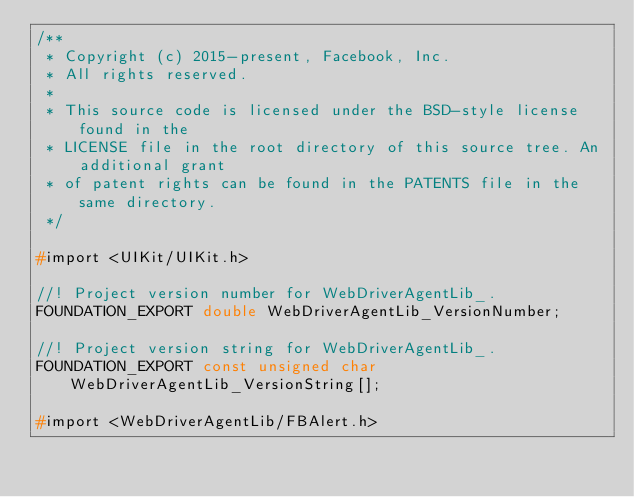<code> <loc_0><loc_0><loc_500><loc_500><_C_>/**
 * Copyright (c) 2015-present, Facebook, Inc.
 * All rights reserved.
 *
 * This source code is licensed under the BSD-style license found in the
 * LICENSE file in the root directory of this source tree. An additional grant
 * of patent rights can be found in the PATENTS file in the same directory.
 */

#import <UIKit/UIKit.h>

//! Project version number for WebDriverAgentLib_.
FOUNDATION_EXPORT double WebDriverAgentLib_VersionNumber;

//! Project version string for WebDriverAgentLib_.
FOUNDATION_EXPORT const unsigned char WebDriverAgentLib_VersionString[];

#import <WebDriverAgentLib/FBAlert.h></code> 